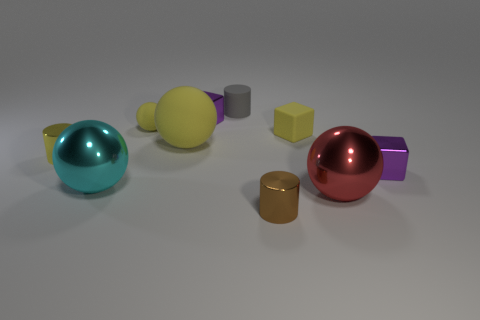Subtract 1 balls. How many balls are left? 3 Subtract all cylinders. How many objects are left? 7 Add 2 yellow matte balls. How many yellow matte balls exist? 4 Subtract 0 green cylinders. How many objects are left? 10 Subtract all big gray things. Subtract all gray cylinders. How many objects are left? 9 Add 1 small purple cubes. How many small purple cubes are left? 3 